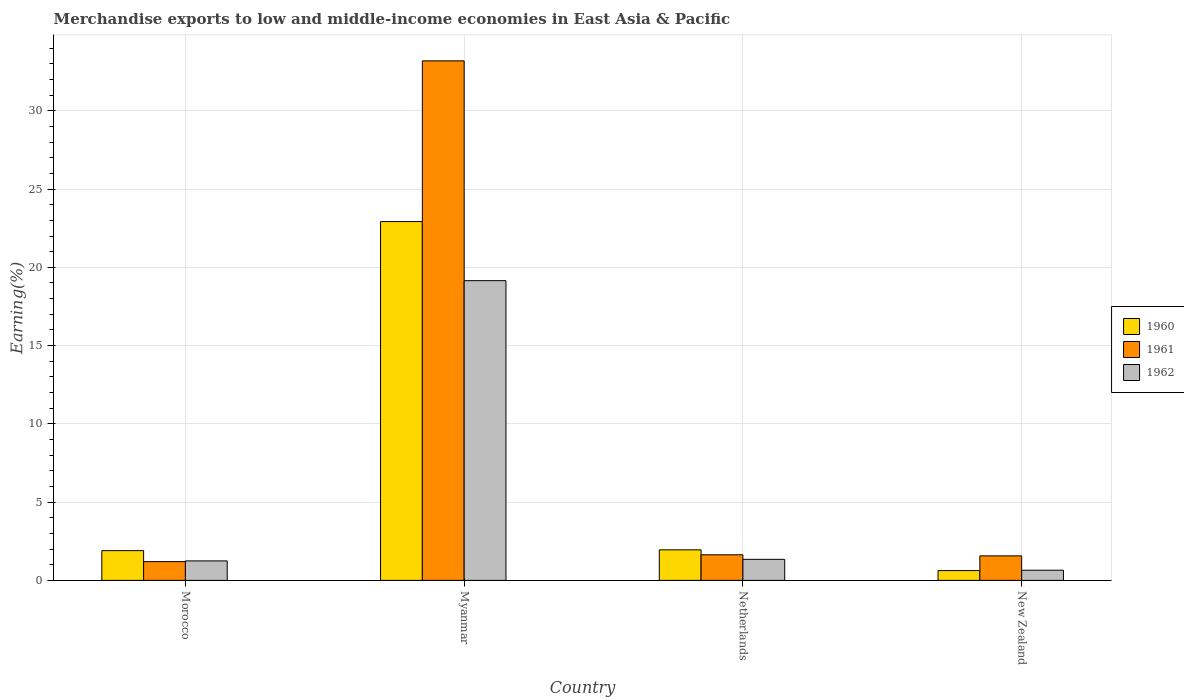Are the number of bars on each tick of the X-axis equal?
Offer a terse response. Yes. How many bars are there on the 3rd tick from the left?
Provide a succinct answer. 3. What is the label of the 3rd group of bars from the left?
Offer a very short reply. Netherlands. What is the percentage of amount earned from merchandise exports in 1961 in Morocco?
Your response must be concise. 1.2. Across all countries, what is the maximum percentage of amount earned from merchandise exports in 1960?
Give a very brief answer. 22.92. Across all countries, what is the minimum percentage of amount earned from merchandise exports in 1962?
Your answer should be compact. 0.65. In which country was the percentage of amount earned from merchandise exports in 1960 maximum?
Your answer should be very brief. Myanmar. In which country was the percentage of amount earned from merchandise exports in 1960 minimum?
Provide a succinct answer. New Zealand. What is the total percentage of amount earned from merchandise exports in 1960 in the graph?
Provide a short and direct response. 27.4. What is the difference between the percentage of amount earned from merchandise exports in 1960 in Netherlands and that in New Zealand?
Your answer should be very brief. 1.32. What is the difference between the percentage of amount earned from merchandise exports in 1962 in Morocco and the percentage of amount earned from merchandise exports in 1961 in New Zealand?
Keep it short and to the point. -0.32. What is the average percentage of amount earned from merchandise exports in 1960 per country?
Your answer should be very brief. 6.85. What is the difference between the percentage of amount earned from merchandise exports of/in 1960 and percentage of amount earned from merchandise exports of/in 1961 in New Zealand?
Your answer should be compact. -0.94. In how many countries, is the percentage of amount earned from merchandise exports in 1960 greater than 26 %?
Offer a very short reply. 0. What is the ratio of the percentage of amount earned from merchandise exports in 1961 in Myanmar to that in New Zealand?
Your answer should be very brief. 21.19. Is the difference between the percentage of amount earned from merchandise exports in 1960 in Myanmar and Netherlands greater than the difference between the percentage of amount earned from merchandise exports in 1961 in Myanmar and Netherlands?
Give a very brief answer. No. What is the difference between the highest and the second highest percentage of amount earned from merchandise exports in 1960?
Offer a very short reply. 0.05. What is the difference between the highest and the lowest percentage of amount earned from merchandise exports in 1961?
Offer a very short reply. 31.99. Is the sum of the percentage of amount earned from merchandise exports in 1961 in Myanmar and Netherlands greater than the maximum percentage of amount earned from merchandise exports in 1960 across all countries?
Make the answer very short. Yes. What does the 3rd bar from the left in Netherlands represents?
Provide a short and direct response. 1962. How many bars are there?
Provide a succinct answer. 12. How many countries are there in the graph?
Provide a short and direct response. 4. What is the difference between two consecutive major ticks on the Y-axis?
Provide a short and direct response. 5. Are the values on the major ticks of Y-axis written in scientific E-notation?
Offer a very short reply. No. Does the graph contain any zero values?
Make the answer very short. No. Where does the legend appear in the graph?
Make the answer very short. Center right. How many legend labels are there?
Keep it short and to the point. 3. How are the legend labels stacked?
Keep it short and to the point. Vertical. What is the title of the graph?
Keep it short and to the point. Merchandise exports to low and middle-income economies in East Asia & Pacific. Does "1986" appear as one of the legend labels in the graph?
Ensure brevity in your answer.  No. What is the label or title of the Y-axis?
Your response must be concise. Earning(%). What is the Earning(%) of 1960 in Morocco?
Make the answer very short. 1.9. What is the Earning(%) in 1961 in Morocco?
Provide a succinct answer. 1.2. What is the Earning(%) in 1962 in Morocco?
Give a very brief answer. 1.25. What is the Earning(%) in 1960 in Myanmar?
Provide a short and direct response. 22.92. What is the Earning(%) of 1961 in Myanmar?
Ensure brevity in your answer.  33.19. What is the Earning(%) of 1962 in Myanmar?
Your answer should be very brief. 19.15. What is the Earning(%) of 1960 in Netherlands?
Give a very brief answer. 1.95. What is the Earning(%) in 1961 in Netherlands?
Keep it short and to the point. 1.63. What is the Earning(%) of 1962 in Netherlands?
Provide a short and direct response. 1.35. What is the Earning(%) in 1960 in New Zealand?
Keep it short and to the point. 0.63. What is the Earning(%) in 1961 in New Zealand?
Keep it short and to the point. 1.57. What is the Earning(%) in 1962 in New Zealand?
Provide a succinct answer. 0.65. Across all countries, what is the maximum Earning(%) in 1960?
Provide a succinct answer. 22.92. Across all countries, what is the maximum Earning(%) in 1961?
Your answer should be compact. 33.19. Across all countries, what is the maximum Earning(%) of 1962?
Your response must be concise. 19.15. Across all countries, what is the minimum Earning(%) in 1960?
Ensure brevity in your answer.  0.63. Across all countries, what is the minimum Earning(%) of 1961?
Provide a succinct answer. 1.2. Across all countries, what is the minimum Earning(%) in 1962?
Your response must be concise. 0.65. What is the total Earning(%) of 1960 in the graph?
Offer a terse response. 27.4. What is the total Earning(%) of 1961 in the graph?
Provide a short and direct response. 37.59. What is the total Earning(%) of 1962 in the graph?
Ensure brevity in your answer.  22.39. What is the difference between the Earning(%) in 1960 in Morocco and that in Myanmar?
Your answer should be compact. -21.02. What is the difference between the Earning(%) in 1961 in Morocco and that in Myanmar?
Your response must be concise. -31.99. What is the difference between the Earning(%) in 1962 in Morocco and that in Myanmar?
Provide a short and direct response. -17.9. What is the difference between the Earning(%) of 1960 in Morocco and that in Netherlands?
Provide a succinct answer. -0.05. What is the difference between the Earning(%) in 1961 in Morocco and that in Netherlands?
Make the answer very short. -0.43. What is the difference between the Earning(%) in 1962 in Morocco and that in Netherlands?
Your response must be concise. -0.1. What is the difference between the Earning(%) of 1960 in Morocco and that in New Zealand?
Make the answer very short. 1.27. What is the difference between the Earning(%) of 1961 in Morocco and that in New Zealand?
Your response must be concise. -0.37. What is the difference between the Earning(%) in 1962 in Morocco and that in New Zealand?
Your answer should be compact. 0.6. What is the difference between the Earning(%) of 1960 in Myanmar and that in Netherlands?
Your response must be concise. 20.97. What is the difference between the Earning(%) in 1961 in Myanmar and that in Netherlands?
Offer a terse response. 31.56. What is the difference between the Earning(%) of 1962 in Myanmar and that in Netherlands?
Provide a succinct answer. 17.8. What is the difference between the Earning(%) of 1960 in Myanmar and that in New Zealand?
Offer a very short reply. 22.3. What is the difference between the Earning(%) of 1961 in Myanmar and that in New Zealand?
Ensure brevity in your answer.  31.62. What is the difference between the Earning(%) in 1962 in Myanmar and that in New Zealand?
Make the answer very short. 18.5. What is the difference between the Earning(%) in 1960 in Netherlands and that in New Zealand?
Your answer should be very brief. 1.32. What is the difference between the Earning(%) of 1961 in Netherlands and that in New Zealand?
Your response must be concise. 0.07. What is the difference between the Earning(%) in 1962 in Netherlands and that in New Zealand?
Keep it short and to the point. 0.7. What is the difference between the Earning(%) of 1960 in Morocco and the Earning(%) of 1961 in Myanmar?
Provide a succinct answer. -31.29. What is the difference between the Earning(%) of 1960 in Morocco and the Earning(%) of 1962 in Myanmar?
Provide a succinct answer. -17.25. What is the difference between the Earning(%) of 1961 in Morocco and the Earning(%) of 1962 in Myanmar?
Keep it short and to the point. -17.95. What is the difference between the Earning(%) in 1960 in Morocco and the Earning(%) in 1961 in Netherlands?
Provide a succinct answer. 0.27. What is the difference between the Earning(%) in 1960 in Morocco and the Earning(%) in 1962 in Netherlands?
Offer a very short reply. 0.56. What is the difference between the Earning(%) in 1961 in Morocco and the Earning(%) in 1962 in Netherlands?
Ensure brevity in your answer.  -0.15. What is the difference between the Earning(%) in 1960 in Morocco and the Earning(%) in 1961 in New Zealand?
Give a very brief answer. 0.33. What is the difference between the Earning(%) in 1960 in Morocco and the Earning(%) in 1962 in New Zealand?
Give a very brief answer. 1.25. What is the difference between the Earning(%) in 1961 in Morocco and the Earning(%) in 1962 in New Zealand?
Offer a very short reply. 0.55. What is the difference between the Earning(%) in 1960 in Myanmar and the Earning(%) in 1961 in Netherlands?
Provide a succinct answer. 21.29. What is the difference between the Earning(%) of 1960 in Myanmar and the Earning(%) of 1962 in Netherlands?
Provide a short and direct response. 21.58. What is the difference between the Earning(%) in 1961 in Myanmar and the Earning(%) in 1962 in Netherlands?
Give a very brief answer. 31.85. What is the difference between the Earning(%) of 1960 in Myanmar and the Earning(%) of 1961 in New Zealand?
Your answer should be very brief. 21.36. What is the difference between the Earning(%) of 1960 in Myanmar and the Earning(%) of 1962 in New Zealand?
Keep it short and to the point. 22.27. What is the difference between the Earning(%) in 1961 in Myanmar and the Earning(%) in 1962 in New Zealand?
Give a very brief answer. 32.54. What is the difference between the Earning(%) in 1960 in Netherlands and the Earning(%) in 1961 in New Zealand?
Provide a short and direct response. 0.39. What is the difference between the Earning(%) in 1960 in Netherlands and the Earning(%) in 1962 in New Zealand?
Make the answer very short. 1.3. What is the difference between the Earning(%) in 1961 in Netherlands and the Earning(%) in 1962 in New Zealand?
Provide a succinct answer. 0.98. What is the average Earning(%) of 1960 per country?
Your answer should be compact. 6.85. What is the average Earning(%) in 1961 per country?
Give a very brief answer. 9.4. What is the average Earning(%) in 1962 per country?
Offer a very short reply. 5.6. What is the difference between the Earning(%) of 1960 and Earning(%) of 1961 in Morocco?
Offer a very short reply. 0.7. What is the difference between the Earning(%) in 1960 and Earning(%) in 1962 in Morocco?
Offer a terse response. 0.66. What is the difference between the Earning(%) in 1961 and Earning(%) in 1962 in Morocco?
Ensure brevity in your answer.  -0.05. What is the difference between the Earning(%) in 1960 and Earning(%) in 1961 in Myanmar?
Make the answer very short. -10.27. What is the difference between the Earning(%) of 1960 and Earning(%) of 1962 in Myanmar?
Provide a short and direct response. 3.78. What is the difference between the Earning(%) of 1961 and Earning(%) of 1962 in Myanmar?
Provide a short and direct response. 14.04. What is the difference between the Earning(%) of 1960 and Earning(%) of 1961 in Netherlands?
Give a very brief answer. 0.32. What is the difference between the Earning(%) in 1960 and Earning(%) in 1962 in Netherlands?
Provide a succinct answer. 0.61. What is the difference between the Earning(%) in 1961 and Earning(%) in 1962 in Netherlands?
Ensure brevity in your answer.  0.29. What is the difference between the Earning(%) in 1960 and Earning(%) in 1961 in New Zealand?
Give a very brief answer. -0.94. What is the difference between the Earning(%) of 1960 and Earning(%) of 1962 in New Zealand?
Ensure brevity in your answer.  -0.02. What is the difference between the Earning(%) of 1961 and Earning(%) of 1962 in New Zealand?
Provide a succinct answer. 0.92. What is the ratio of the Earning(%) of 1960 in Morocco to that in Myanmar?
Your answer should be compact. 0.08. What is the ratio of the Earning(%) in 1961 in Morocco to that in Myanmar?
Your response must be concise. 0.04. What is the ratio of the Earning(%) of 1962 in Morocco to that in Myanmar?
Make the answer very short. 0.07. What is the ratio of the Earning(%) in 1960 in Morocco to that in Netherlands?
Your answer should be very brief. 0.97. What is the ratio of the Earning(%) of 1961 in Morocco to that in Netherlands?
Your answer should be compact. 0.73. What is the ratio of the Earning(%) in 1962 in Morocco to that in Netherlands?
Ensure brevity in your answer.  0.93. What is the ratio of the Earning(%) in 1960 in Morocco to that in New Zealand?
Offer a terse response. 3.03. What is the ratio of the Earning(%) in 1961 in Morocco to that in New Zealand?
Your answer should be compact. 0.77. What is the ratio of the Earning(%) in 1962 in Morocco to that in New Zealand?
Ensure brevity in your answer.  1.92. What is the ratio of the Earning(%) in 1960 in Myanmar to that in Netherlands?
Your response must be concise. 11.75. What is the ratio of the Earning(%) in 1961 in Myanmar to that in Netherlands?
Offer a terse response. 20.31. What is the ratio of the Earning(%) in 1962 in Myanmar to that in Netherlands?
Offer a very short reply. 14.23. What is the ratio of the Earning(%) in 1960 in Myanmar to that in New Zealand?
Your answer should be compact. 36.54. What is the ratio of the Earning(%) in 1961 in Myanmar to that in New Zealand?
Keep it short and to the point. 21.19. What is the ratio of the Earning(%) in 1962 in Myanmar to that in New Zealand?
Your answer should be compact. 29.51. What is the ratio of the Earning(%) of 1960 in Netherlands to that in New Zealand?
Ensure brevity in your answer.  3.11. What is the ratio of the Earning(%) in 1961 in Netherlands to that in New Zealand?
Offer a terse response. 1.04. What is the ratio of the Earning(%) of 1962 in Netherlands to that in New Zealand?
Your answer should be very brief. 2.07. What is the difference between the highest and the second highest Earning(%) in 1960?
Offer a very short reply. 20.97. What is the difference between the highest and the second highest Earning(%) in 1961?
Keep it short and to the point. 31.56. What is the difference between the highest and the second highest Earning(%) of 1962?
Provide a succinct answer. 17.8. What is the difference between the highest and the lowest Earning(%) in 1960?
Ensure brevity in your answer.  22.3. What is the difference between the highest and the lowest Earning(%) in 1961?
Your answer should be compact. 31.99. What is the difference between the highest and the lowest Earning(%) of 1962?
Keep it short and to the point. 18.5. 